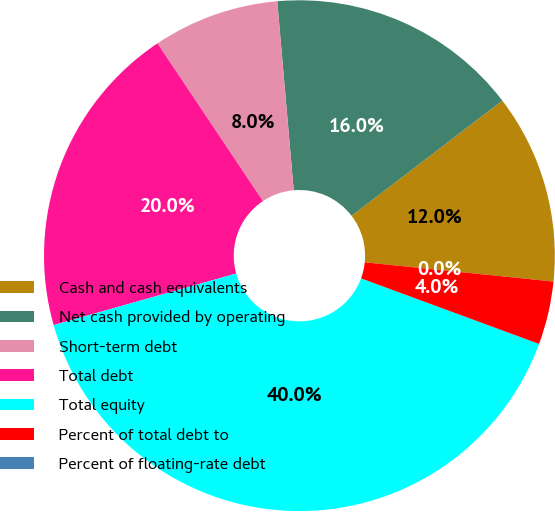<chart> <loc_0><loc_0><loc_500><loc_500><pie_chart><fcel>Cash and cash equivalents<fcel>Net cash provided by operating<fcel>Short-term debt<fcel>Total debt<fcel>Total equity<fcel>Percent of total debt to<fcel>Percent of floating-rate debt<nl><fcel>12.0%<fcel>16.0%<fcel>8.0%<fcel>20.0%<fcel>40.0%<fcel>4.0%<fcel>0.0%<nl></chart> 